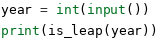<code> <loc_0><loc_0><loc_500><loc_500><_Python_>
year = int(input())
print(is_leap(year))</code> 